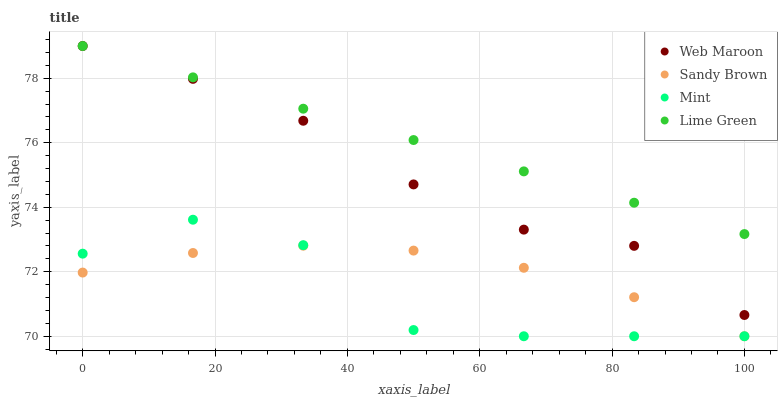Does Mint have the minimum area under the curve?
Answer yes or no. Yes. Does Lime Green have the maximum area under the curve?
Answer yes or no. Yes. Does Web Maroon have the minimum area under the curve?
Answer yes or no. No. Does Web Maroon have the maximum area under the curve?
Answer yes or no. No. Is Lime Green the smoothest?
Answer yes or no. Yes. Is Mint the roughest?
Answer yes or no. Yes. Is Web Maroon the smoothest?
Answer yes or no. No. Is Web Maroon the roughest?
Answer yes or no. No. Does Sandy Brown have the lowest value?
Answer yes or no. Yes. Does Web Maroon have the lowest value?
Answer yes or no. No. Does Lime Green have the highest value?
Answer yes or no. Yes. Does Mint have the highest value?
Answer yes or no. No. Is Sandy Brown less than Web Maroon?
Answer yes or no. Yes. Is Lime Green greater than Sandy Brown?
Answer yes or no. Yes. Does Lime Green intersect Web Maroon?
Answer yes or no. Yes. Is Lime Green less than Web Maroon?
Answer yes or no. No. Is Lime Green greater than Web Maroon?
Answer yes or no. No. Does Sandy Brown intersect Web Maroon?
Answer yes or no. No. 